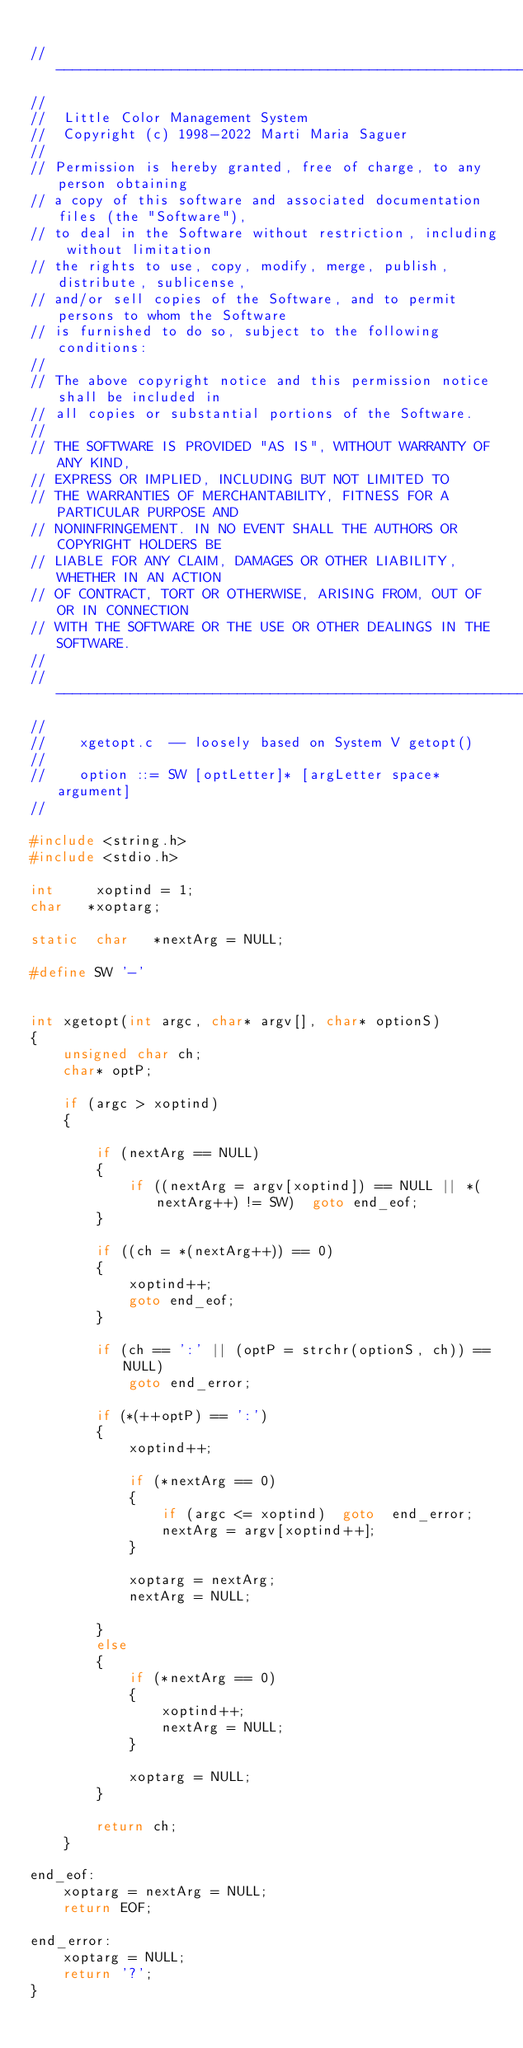<code> <loc_0><loc_0><loc_500><loc_500><_C_>
//---------------------------------------------------------------------------------
//
//  Little Color Management System
//  Copyright (c) 1998-2022 Marti Maria Saguer
//
// Permission is hereby granted, free of charge, to any person obtaining
// a copy of this software and associated documentation files (the "Software"),
// to deal in the Software without restriction, including without limitation
// the rights to use, copy, modify, merge, publish, distribute, sublicense,
// and/or sell copies of the Software, and to permit persons to whom the Software
// is furnished to do so, subject to the following conditions:
//
// The above copyright notice and this permission notice shall be included in
// all copies or substantial portions of the Software.
//
// THE SOFTWARE IS PROVIDED "AS IS", WITHOUT WARRANTY OF ANY KIND,
// EXPRESS OR IMPLIED, INCLUDING BUT NOT LIMITED TO
// THE WARRANTIES OF MERCHANTABILITY, FITNESS FOR A PARTICULAR PURPOSE AND
// NONINFRINGEMENT. IN NO EVENT SHALL THE AUTHORS OR COPYRIGHT HOLDERS BE
// LIABLE FOR ANY CLAIM, DAMAGES OR OTHER LIABILITY, WHETHER IN AN ACTION
// OF CONTRACT, TORT OR OTHERWISE, ARISING FROM, OUT OF OR IN CONNECTION
// WITH THE SOFTWARE OR THE USE OR OTHER DEALINGS IN THE SOFTWARE.
//
//---------------------------------------------------------------------------------
//
//    xgetopt.c  -- loosely based on System V getopt()
//
//    option ::= SW [optLetter]* [argLetter space* argument]
//   

#include <string.h>
#include <stdio.h>

int     xoptind = 1;   
char   *xoptarg;       

static  char   *nextArg = NULL;    

#define SW '-'


int xgetopt(int argc, char* argv[], char* optionS)
{
    unsigned char ch;
    char* optP;

    if (argc > xoptind)
    {

        if (nextArg == NULL)
        {
            if ((nextArg = argv[xoptind]) == NULL || *(nextArg++) != SW)  goto end_eof;
        }

        if ((ch = *(nextArg++)) == 0)
        {
            xoptind++;
            goto end_eof;
        }

        if (ch == ':' || (optP = strchr(optionS, ch)) == NULL)
            goto end_error;

        if (*(++optP) == ':')
        {
            xoptind++;

            if (*nextArg == 0)
            {
                if (argc <= xoptind)  goto  end_error;
                nextArg = argv[xoptind++];
            }

            xoptarg = nextArg;
            nextArg = NULL;

        }
        else
        {
            if (*nextArg == 0)
            {
                xoptind++;
                nextArg = NULL;
            }

            xoptarg = NULL;
        }

        return ch;
    }

end_eof:
    xoptarg = nextArg = NULL;
    return EOF;

end_error:
    xoptarg = NULL;
    return '?';
}
</code> 